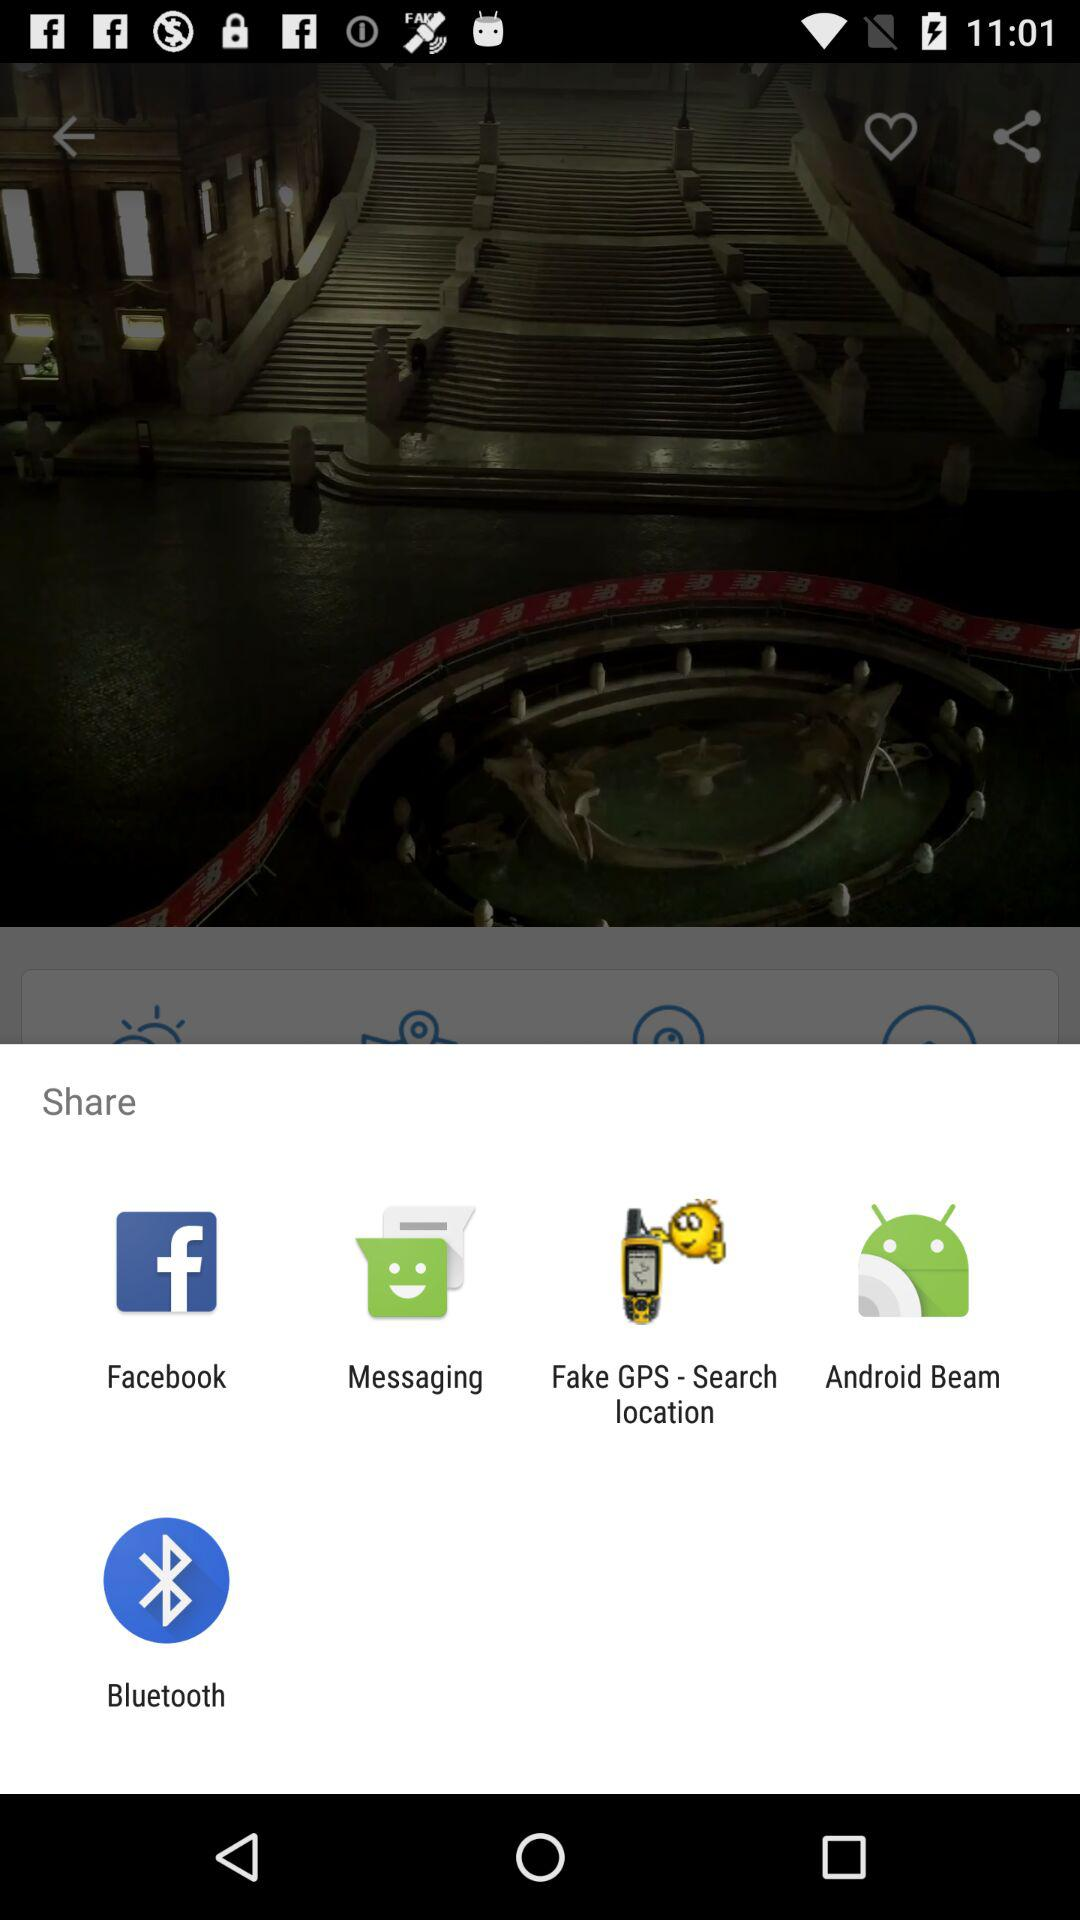What is the name of the application?
When the provided information is insufficient, respond with <no answer>. <no answer> 